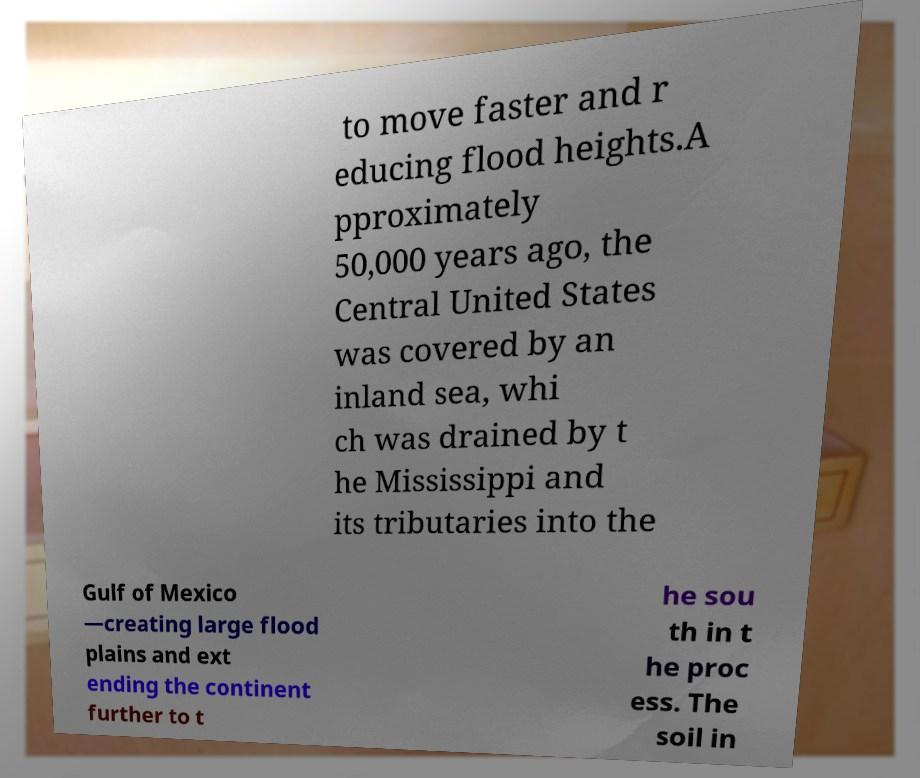Can you read and provide the text displayed in the image?This photo seems to have some interesting text. Can you extract and type it out for me? to move faster and r educing flood heights.A pproximately 50,000 years ago, the Central United States was covered by an inland sea, whi ch was drained by t he Mississippi and its tributaries into the Gulf of Mexico —creating large flood plains and ext ending the continent further to t he sou th in t he proc ess. The soil in 